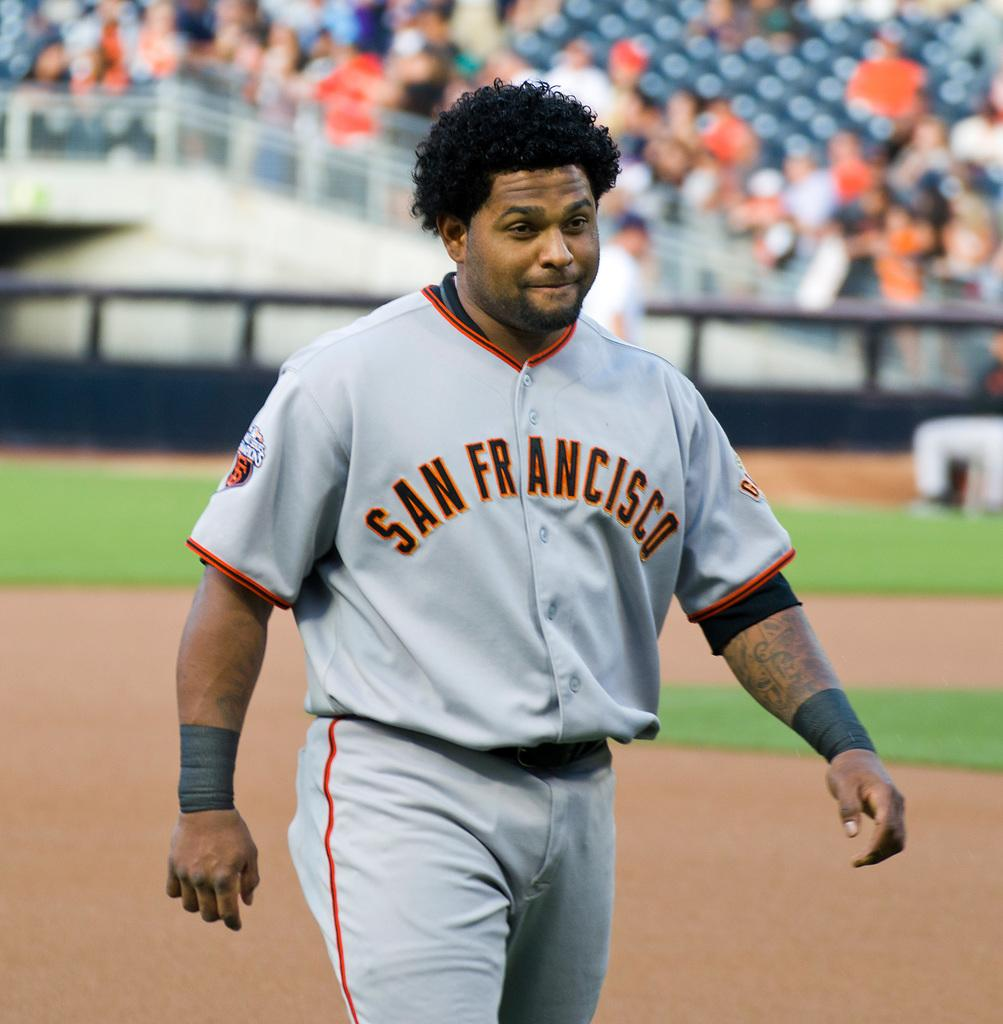<image>
Relay a brief, clear account of the picture shown. A baseball player wearing a grey strip with San Francisco on the front of his top walks on the baseball field. 